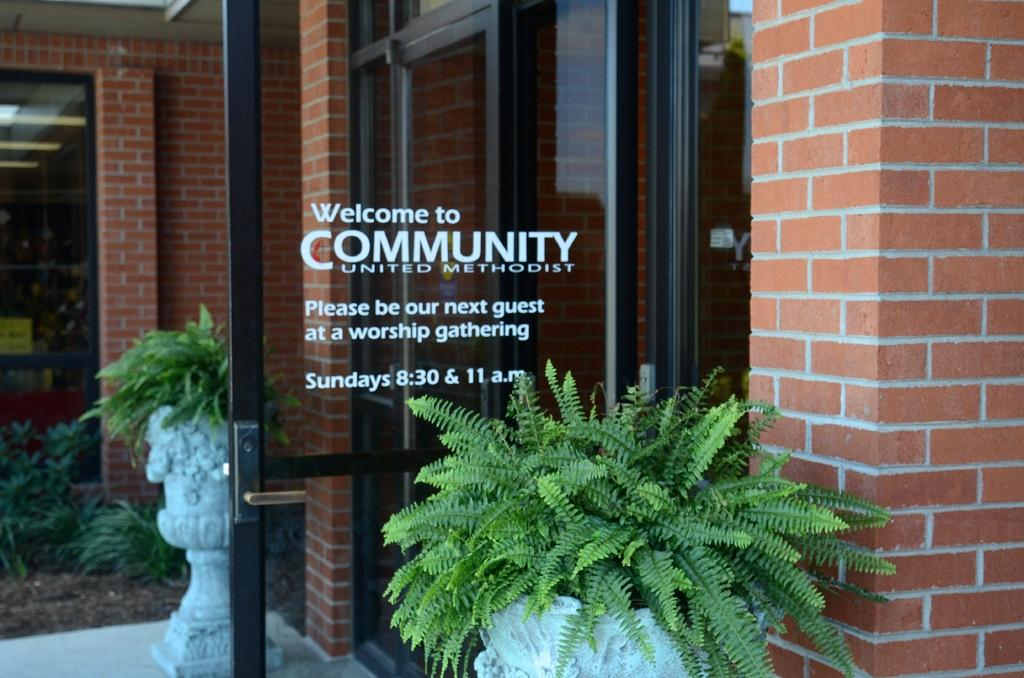What type of objects are in the pots in the image? There are plants in pots in the image. What can be seen on the door in the image? There are words and numbers on the door. What type of illumination is present in the image? There are lights in the image. What is the board used for in the image? The purpose of the board in the image is not specified, but it could be used for displaying information or as a surface for writing or drawing. What type of structure is visible in the image? There is a wall in the image. What type of rat is sitting on the board in the image? There is no rat present in the image. What is the opinion of the plants in the pots about the wall in the image? Plants do not have opinions, so this question cannot be answered. 